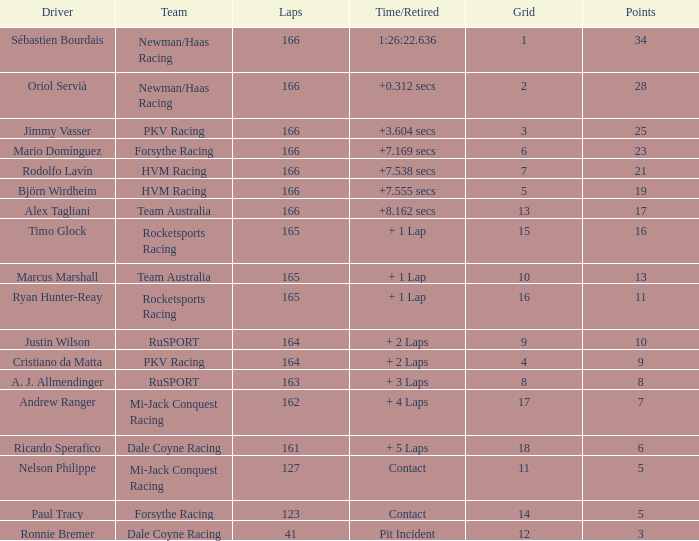What is the name of the driver with 6 points? Ricardo Sperafico. 